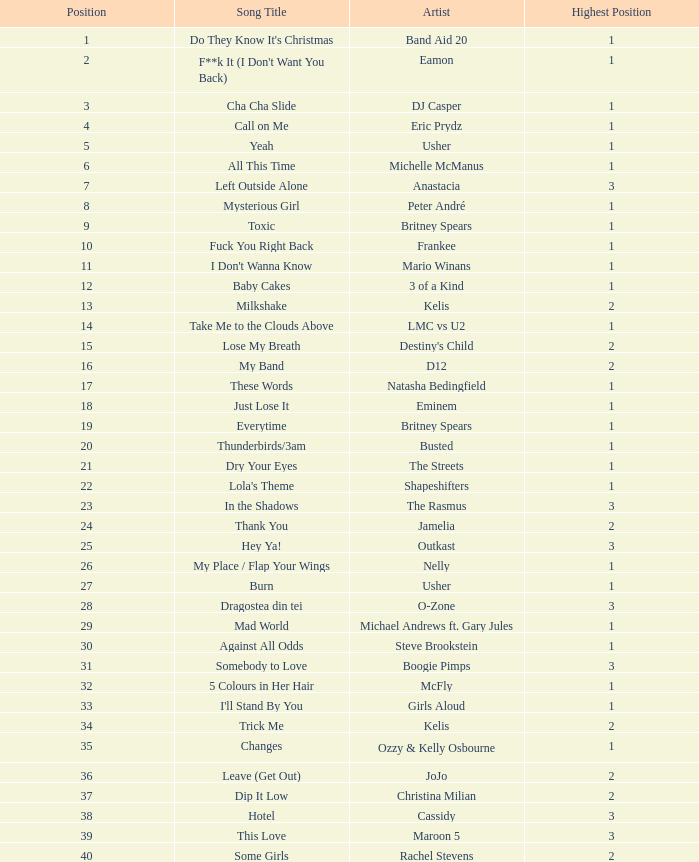What is the most sales by a song with a position higher than 3? None. 